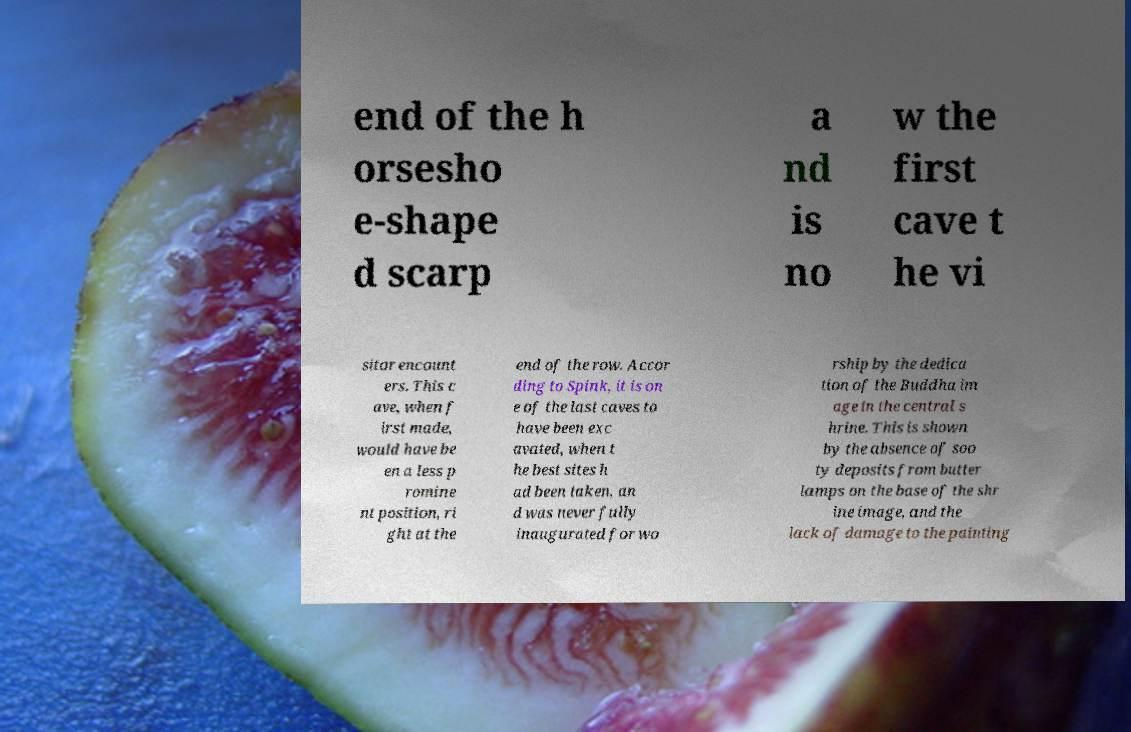Can you accurately transcribe the text from the provided image for me? end of the h orsesho e-shape d scarp a nd is no w the first cave t he vi sitor encount ers. This c ave, when f irst made, would have be en a less p romine nt position, ri ght at the end of the row. Accor ding to Spink, it is on e of the last caves to have been exc avated, when t he best sites h ad been taken, an d was never fully inaugurated for wo rship by the dedica tion of the Buddha im age in the central s hrine. This is shown by the absence of soo ty deposits from butter lamps on the base of the shr ine image, and the lack of damage to the painting 